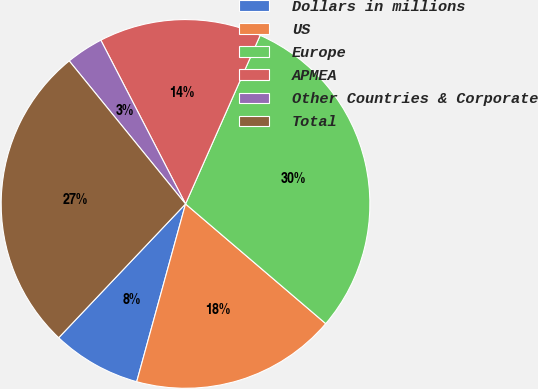<chart> <loc_0><loc_0><loc_500><loc_500><pie_chart><fcel>Dollars in millions<fcel>US<fcel>Europe<fcel>APMEA<fcel>Other Countries & Corporate<fcel>Total<nl><fcel>7.81%<fcel>18.02%<fcel>29.62%<fcel>14.23%<fcel>3.27%<fcel>27.06%<nl></chart> 